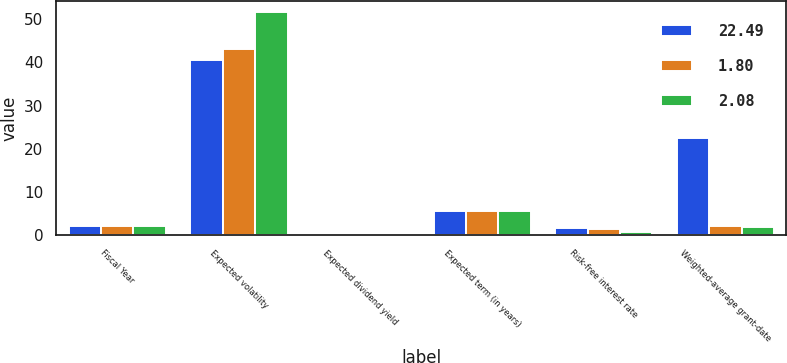Convert chart. <chart><loc_0><loc_0><loc_500><loc_500><stacked_bar_chart><ecel><fcel>Fiscal Year<fcel>Expected volatility<fcel>Expected dividend yield<fcel>Expected term (in years)<fcel>Risk-free interest rate<fcel>Weighted-average grant-date<nl><fcel>22.49<fcel>2.08<fcel>40.6<fcel>0<fcel>5.6<fcel>1.7<fcel>22.49<nl><fcel>1.8<fcel>2.08<fcel>43.2<fcel>0<fcel>5.5<fcel>1.4<fcel>2.08<nl><fcel>2.08<fcel>2.08<fcel>51.6<fcel>0<fcel>5.5<fcel>0.8<fcel>1.8<nl></chart> 